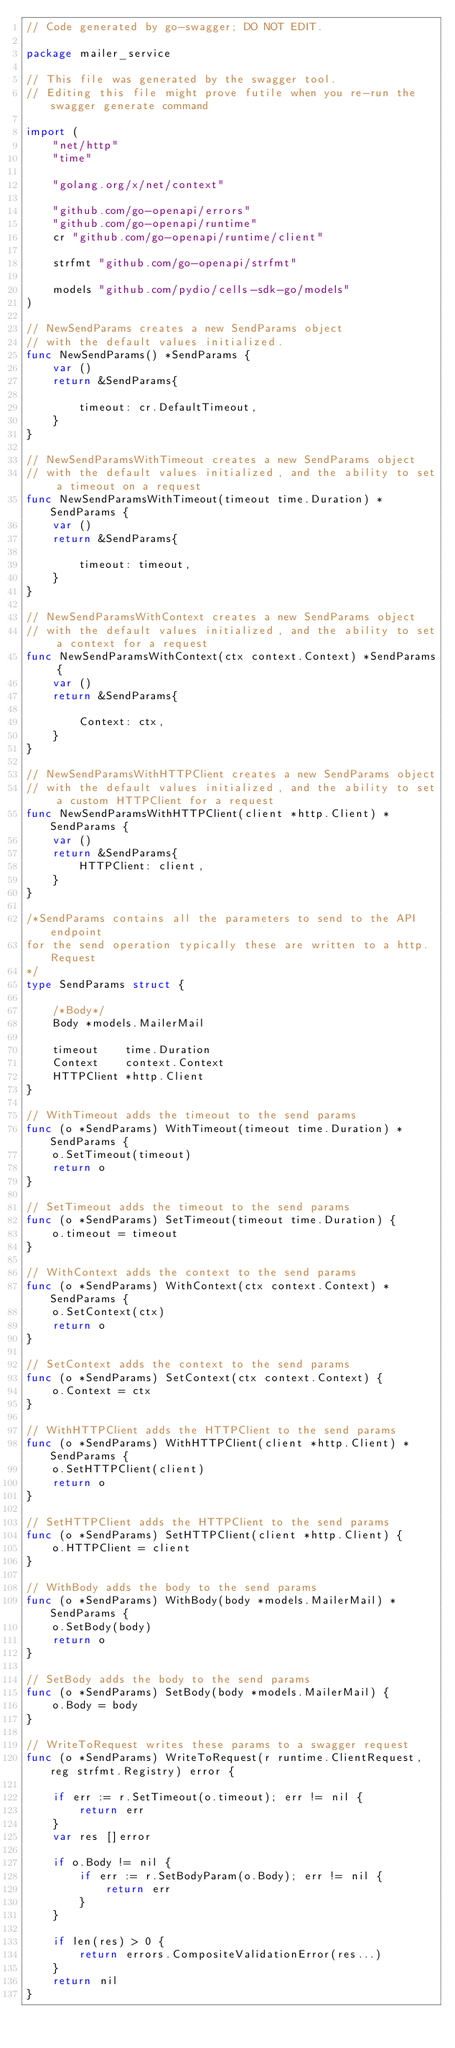Convert code to text. <code><loc_0><loc_0><loc_500><loc_500><_Go_>// Code generated by go-swagger; DO NOT EDIT.

package mailer_service

// This file was generated by the swagger tool.
// Editing this file might prove futile when you re-run the swagger generate command

import (
	"net/http"
	"time"

	"golang.org/x/net/context"

	"github.com/go-openapi/errors"
	"github.com/go-openapi/runtime"
	cr "github.com/go-openapi/runtime/client"

	strfmt "github.com/go-openapi/strfmt"

	models "github.com/pydio/cells-sdk-go/models"
)

// NewSendParams creates a new SendParams object
// with the default values initialized.
func NewSendParams() *SendParams {
	var ()
	return &SendParams{

		timeout: cr.DefaultTimeout,
	}
}

// NewSendParamsWithTimeout creates a new SendParams object
// with the default values initialized, and the ability to set a timeout on a request
func NewSendParamsWithTimeout(timeout time.Duration) *SendParams {
	var ()
	return &SendParams{

		timeout: timeout,
	}
}

// NewSendParamsWithContext creates a new SendParams object
// with the default values initialized, and the ability to set a context for a request
func NewSendParamsWithContext(ctx context.Context) *SendParams {
	var ()
	return &SendParams{

		Context: ctx,
	}
}

// NewSendParamsWithHTTPClient creates a new SendParams object
// with the default values initialized, and the ability to set a custom HTTPClient for a request
func NewSendParamsWithHTTPClient(client *http.Client) *SendParams {
	var ()
	return &SendParams{
		HTTPClient: client,
	}
}

/*SendParams contains all the parameters to send to the API endpoint
for the send operation typically these are written to a http.Request
*/
type SendParams struct {

	/*Body*/
	Body *models.MailerMail

	timeout    time.Duration
	Context    context.Context
	HTTPClient *http.Client
}

// WithTimeout adds the timeout to the send params
func (o *SendParams) WithTimeout(timeout time.Duration) *SendParams {
	o.SetTimeout(timeout)
	return o
}

// SetTimeout adds the timeout to the send params
func (o *SendParams) SetTimeout(timeout time.Duration) {
	o.timeout = timeout
}

// WithContext adds the context to the send params
func (o *SendParams) WithContext(ctx context.Context) *SendParams {
	o.SetContext(ctx)
	return o
}

// SetContext adds the context to the send params
func (o *SendParams) SetContext(ctx context.Context) {
	o.Context = ctx
}

// WithHTTPClient adds the HTTPClient to the send params
func (o *SendParams) WithHTTPClient(client *http.Client) *SendParams {
	o.SetHTTPClient(client)
	return o
}

// SetHTTPClient adds the HTTPClient to the send params
func (o *SendParams) SetHTTPClient(client *http.Client) {
	o.HTTPClient = client
}

// WithBody adds the body to the send params
func (o *SendParams) WithBody(body *models.MailerMail) *SendParams {
	o.SetBody(body)
	return o
}

// SetBody adds the body to the send params
func (o *SendParams) SetBody(body *models.MailerMail) {
	o.Body = body
}

// WriteToRequest writes these params to a swagger request
func (o *SendParams) WriteToRequest(r runtime.ClientRequest, reg strfmt.Registry) error {

	if err := r.SetTimeout(o.timeout); err != nil {
		return err
	}
	var res []error

	if o.Body != nil {
		if err := r.SetBodyParam(o.Body); err != nil {
			return err
		}
	}

	if len(res) > 0 {
		return errors.CompositeValidationError(res...)
	}
	return nil
}
</code> 